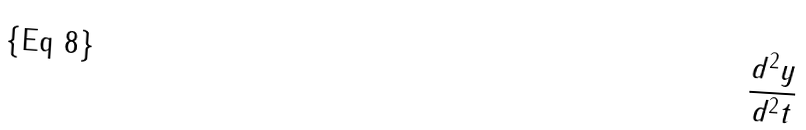<formula> <loc_0><loc_0><loc_500><loc_500>\frac { d ^ { 2 } y } { d ^ { 2 } t }</formula> 